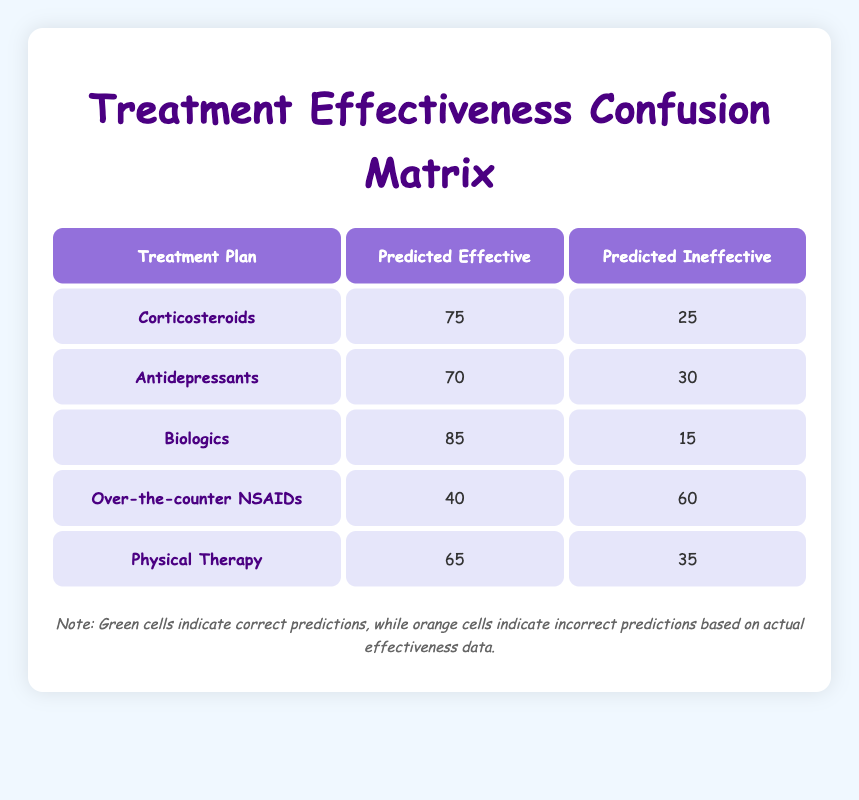What is the predicted effectiveness of Biologics? The table shows that under the "Predicted Effective" column for Biologics, the value is 85.
Answer: 85 Which treatment plan had the highest actual effectiveness? By comparing the values in the "Actual Effective" column, Biologics has the highest value of 90.
Answer: Biologics Did Over-the-counter NSAIDs have a higher actual effectiveness than predicted effectiveness? The actual effectiveness for Over-the-counter NSAIDs is 50, while the predicted effectiveness is 40. Since 50 is greater than 40, the statement is true.
Answer: Yes What is the difference between the actual and predicted effective values for Corticosteroids? For Corticosteroids, the actual effective value is 80 and the predicted effective value is 75. The difference is 80 - 75 = 5.
Answer: 5 Which treatment plan had the most incorrect predictions? To find this, we look at the "Incorrect Prediction" values. Antidepressants have 30 (predicted ineffective) combined with 70 (predicted effective), totalling 100, which is the highest among all treatment plans.
Answer: Antidepressants What percentage of Physical Therapy's predictions were effective? The predicted effectiveness for Physical Therapy is 65, and the total number of predictions is 100 (effectiveness + ineffectiveness). Therefore, the percentage is (65/100) * 100 = 65%.
Answer: 65% Is the prediction for Antidepressants better than that for Physical Therapy? Antidepressants have a predicted effective value of 70 and Physical Therapy has a predicted effective value of 65. Since 70 is greater than 65, the prediction for Antidepressants is better.
Answer: Yes How does the actual effectiveness of Corticosteroids compare to that of Physical Therapy? The actual effectiveness of Corticosteroids is 80, while that of Physical Therapy is 70. Since 80 is greater than 70, Corticosteroids are more effective.
Answer: Higher What is the average predicted effectiveness of all treatment plans? The predicted effectiveness values are 75, 70, 85, 40, and 65. Adding these gives 75 + 70 + 85 + 40 + 65 = 335. To find the average, we divide by the number of treatments (5), resulting in 335 / 5 = 67.
Answer: 67 